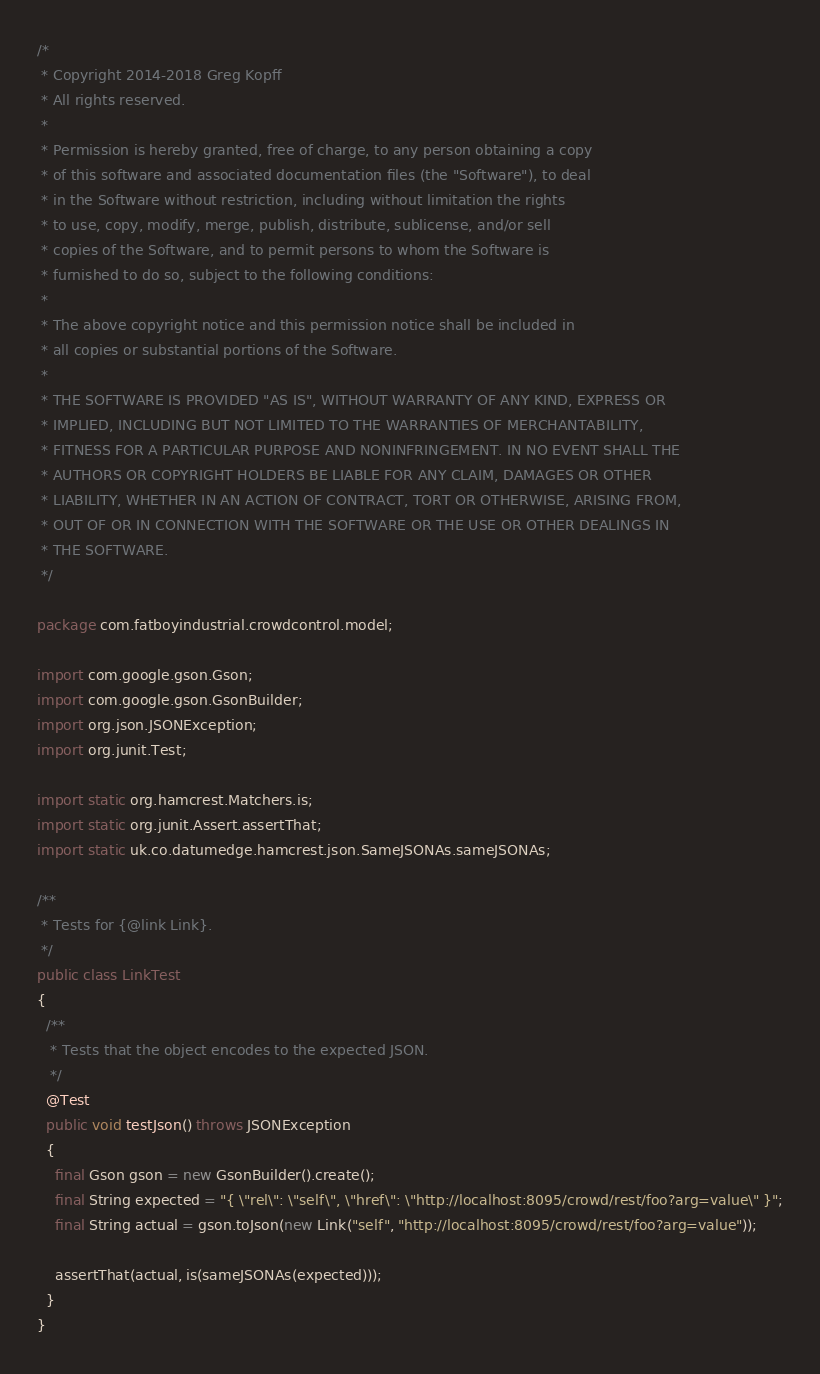<code> <loc_0><loc_0><loc_500><loc_500><_Java_>/*
 * Copyright 2014-2018 Greg Kopff
 * All rights reserved.
 *
 * Permission is hereby granted, free of charge, to any person obtaining a copy
 * of this software and associated documentation files (the "Software"), to deal
 * in the Software without restriction, including without limitation the rights
 * to use, copy, modify, merge, publish, distribute, sublicense, and/or sell
 * copies of the Software, and to permit persons to whom the Software is
 * furnished to do so, subject to the following conditions:
 *
 * The above copyright notice and this permission notice shall be included in
 * all copies or substantial portions of the Software.
 *
 * THE SOFTWARE IS PROVIDED "AS IS", WITHOUT WARRANTY OF ANY KIND, EXPRESS OR
 * IMPLIED, INCLUDING BUT NOT LIMITED TO THE WARRANTIES OF MERCHANTABILITY,
 * FITNESS FOR A PARTICULAR PURPOSE AND NONINFRINGEMENT. IN NO EVENT SHALL THE
 * AUTHORS OR COPYRIGHT HOLDERS BE LIABLE FOR ANY CLAIM, DAMAGES OR OTHER
 * LIABILITY, WHETHER IN AN ACTION OF CONTRACT, TORT OR OTHERWISE, ARISING FROM,
 * OUT OF OR IN CONNECTION WITH THE SOFTWARE OR THE USE OR OTHER DEALINGS IN
 * THE SOFTWARE.
 */

package com.fatboyindustrial.crowdcontrol.model;

import com.google.gson.Gson;
import com.google.gson.GsonBuilder;
import org.json.JSONException;
import org.junit.Test;

import static org.hamcrest.Matchers.is;
import static org.junit.Assert.assertThat;
import static uk.co.datumedge.hamcrest.json.SameJSONAs.sameJSONAs;

/**
 * Tests for {@link Link}.
 */
public class LinkTest
{
  /**
   * Tests that the object encodes to the expected JSON.
   */
  @Test
  public void testJson() throws JSONException
  {
    final Gson gson = new GsonBuilder().create();
    final String expected = "{ \"rel\": \"self\", \"href\": \"http://localhost:8095/crowd/rest/foo?arg=value\" }";
    final String actual = gson.toJson(new Link("self", "http://localhost:8095/crowd/rest/foo?arg=value"));

    assertThat(actual, is(sameJSONAs(expected)));
  }
}
</code> 